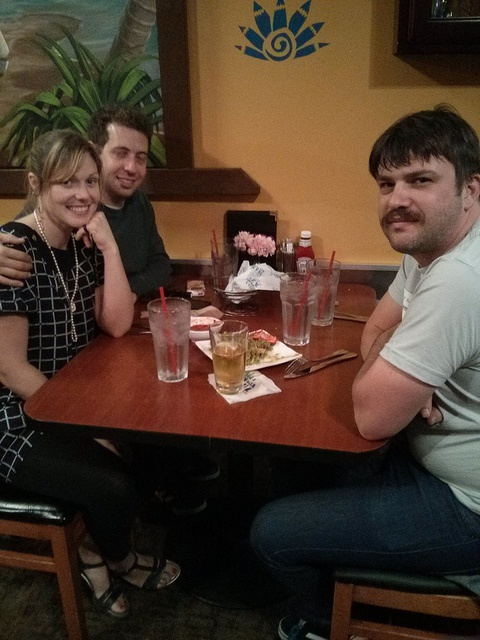Describe the objects in this image and their specific colors. I can see people in teal, black, darkgray, brown, and gray tones, people in teal, black, gray, and maroon tones, dining table in teal, maroon, black, and brown tones, potted plant in teal, black, darkgreen, and gray tones, and people in teal, black, brown, and maroon tones in this image. 